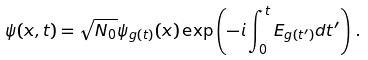Convert formula to latex. <formula><loc_0><loc_0><loc_500><loc_500>\psi ( x , t ) = \sqrt { N _ { 0 } } \psi _ { g ( t ) } ( x ) \exp \left ( - i \int _ { 0 } ^ { t } E _ { g ( t ^ { \prime } ) } d t ^ { \prime } \right ) \, .</formula> 